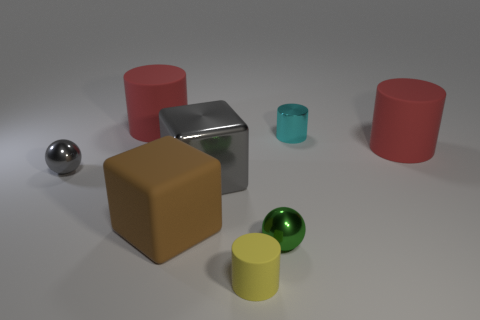Subtract all purple cylinders. Subtract all brown balls. How many cylinders are left? 4 Add 1 red rubber objects. How many objects exist? 9 Subtract all balls. How many objects are left? 6 Subtract all big yellow metal cubes. Subtract all small yellow matte things. How many objects are left? 7 Add 7 matte cylinders. How many matte cylinders are left? 10 Add 7 big green cubes. How many big green cubes exist? 7 Subtract 0 purple cubes. How many objects are left? 8 